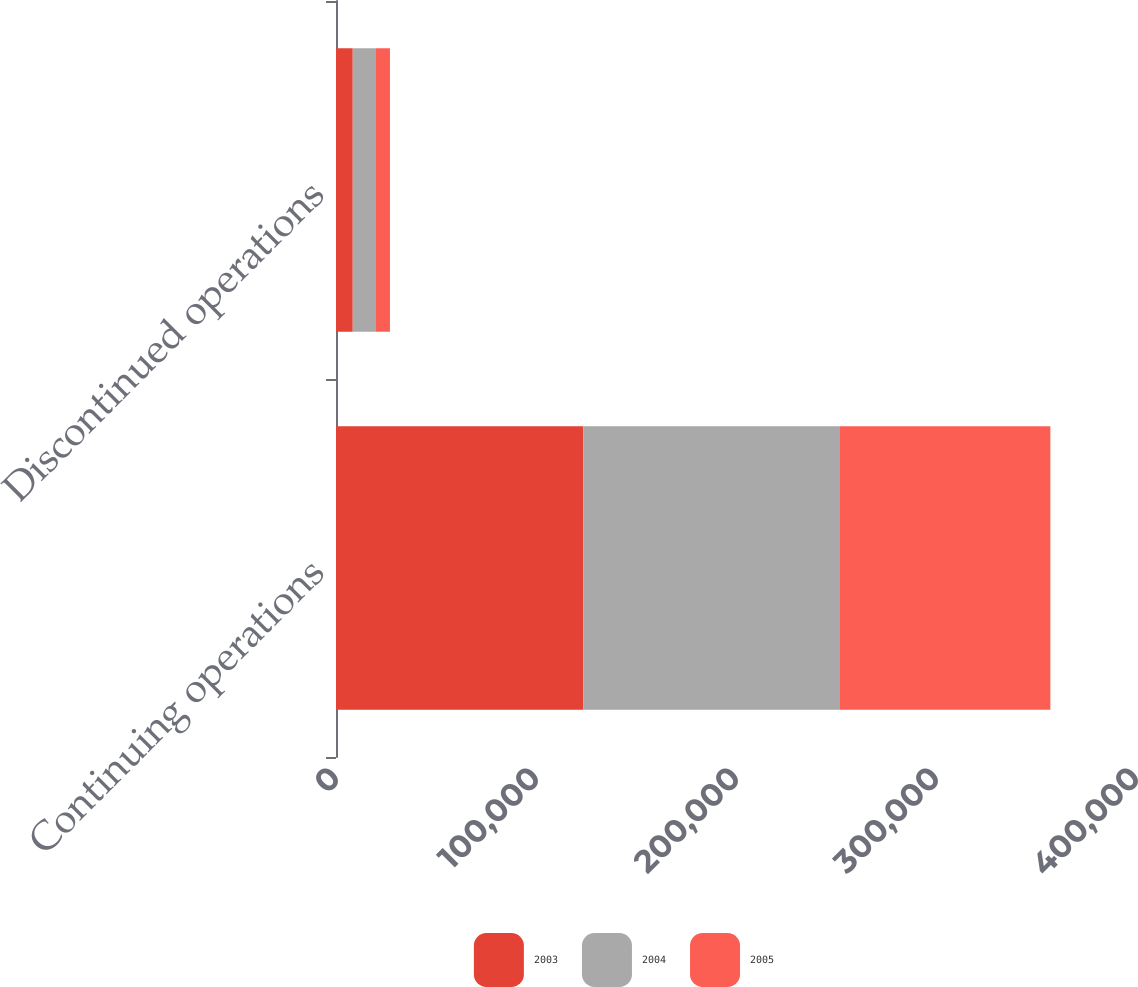Convert chart. <chart><loc_0><loc_0><loc_500><loc_500><stacked_bar_chart><ecel><fcel>Continuing operations<fcel>Discontinued operations<nl><fcel>2003<fcel>123675<fcel>8377<nl><fcel>2004<fcel>128332<fcel>11298<nl><fcel>2005<fcel>105173<fcel>7302<nl></chart> 